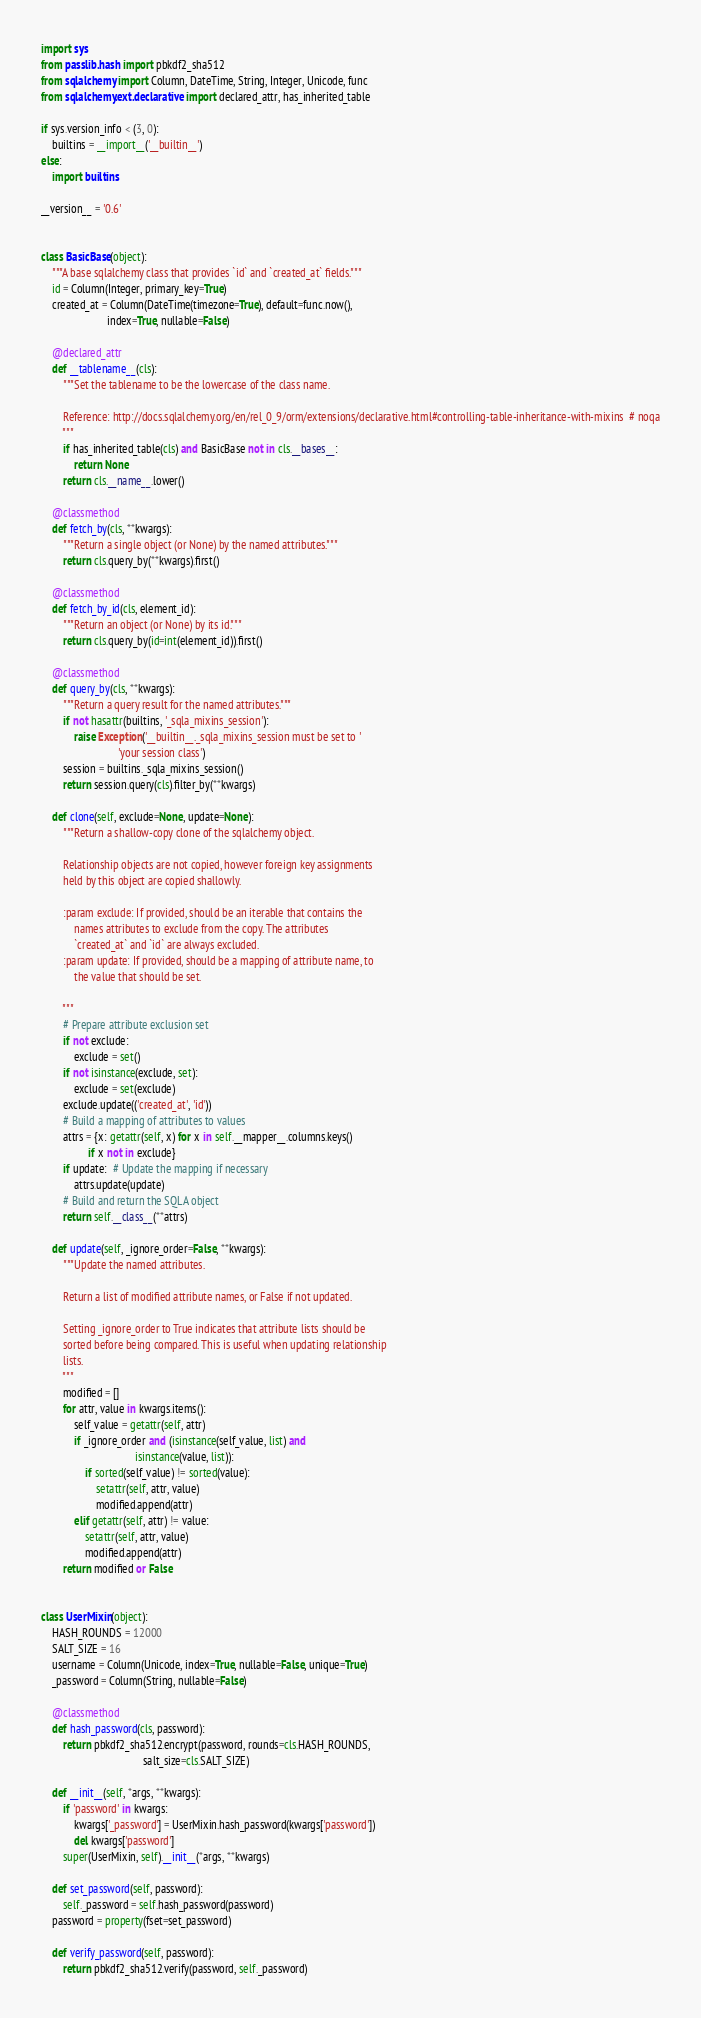Convert code to text. <code><loc_0><loc_0><loc_500><loc_500><_Python_>import sys
from passlib.hash import pbkdf2_sha512
from sqlalchemy import Column, DateTime, String, Integer, Unicode, func
from sqlalchemy.ext.declarative import declared_attr, has_inherited_table

if sys.version_info < (3, 0):
    builtins = __import__('__builtin__')
else:
    import builtins

__version__ = '0.6'


class BasicBase(object):
    """A base sqlalchemy class that provides `id` and `created_at` fields."""
    id = Column(Integer, primary_key=True)
    created_at = Column(DateTime(timezone=True), default=func.now(),
                        index=True, nullable=False)

    @declared_attr
    def __tablename__(cls):
        """Set the tablename to be the lowercase of the class name.

        Reference: http://docs.sqlalchemy.org/en/rel_0_9/orm/extensions/declarative.html#controlling-table-inheritance-with-mixins  # noqa
        """
        if has_inherited_table(cls) and BasicBase not in cls.__bases__:
            return None
        return cls.__name__.lower()

    @classmethod
    def fetch_by(cls, **kwargs):
        """Return a single object (or None) by the named attributes."""
        return cls.query_by(**kwargs).first()

    @classmethod
    def fetch_by_id(cls, element_id):
        """Return an object (or None) by its id."""
        return cls.query_by(id=int(element_id)).first()

    @classmethod
    def query_by(cls, **kwargs):
        """Return a query result for the named attributes."""
        if not hasattr(builtins, '_sqla_mixins_session'):
            raise Exception('__builtin__._sqla_mixins_session must be set to '
                            'your session class')
        session = builtins._sqla_mixins_session()
        return session.query(cls).filter_by(**kwargs)

    def clone(self, exclude=None, update=None):
        """Return a shallow-copy clone of the sqlalchemy object.

        Relationship objects are not copied, however foreign key assignments
        held by this object are copied shallowly.

        :param exclude: If provided, should be an iterable that contains the
            names attributes to exclude from the copy. The attributes
            `created_at` and `id` are always excluded.
        :param update: If provided, should be a mapping of attribute name, to
            the value that should be set.

        """
        # Prepare attribute exclusion set
        if not exclude:
            exclude = set()
        if not isinstance(exclude, set):
            exclude = set(exclude)
        exclude.update(('created_at', 'id'))
        # Build a mapping of attributes to values
        attrs = {x: getattr(self, x) for x in self.__mapper__.columns.keys()
                 if x not in exclude}
        if update:  # Update the mapping if necessary
            attrs.update(update)
        # Build and return the SQLA object
        return self.__class__(**attrs)

    def update(self, _ignore_order=False, **kwargs):
        """Update the named attributes.

        Return a list of modified attribute names, or False if not updated.

        Setting _ignore_order to True indicates that attribute lists should be
        sorted before being compared. This is useful when updating relationship
        lists.
        """
        modified = []
        for attr, value in kwargs.items():
            self_value = getattr(self, attr)
            if _ignore_order and (isinstance(self_value, list) and
                                  isinstance(value, list)):
                if sorted(self_value) != sorted(value):
                    setattr(self, attr, value)
                    modified.append(attr)
            elif getattr(self, attr) != value:
                setattr(self, attr, value)
                modified.append(attr)
        return modified or False


class UserMixin(object):
    HASH_ROUNDS = 12000
    SALT_SIZE = 16
    username = Column(Unicode, index=True, nullable=False, unique=True)
    _password = Column(String, nullable=False)

    @classmethod
    def hash_password(cls, password):
        return pbkdf2_sha512.encrypt(password, rounds=cls.HASH_ROUNDS,
                                     salt_size=cls.SALT_SIZE)

    def __init__(self, *args, **kwargs):
        if 'password' in kwargs:
            kwargs['_password'] = UserMixin.hash_password(kwargs['password'])
            del kwargs['password']
        super(UserMixin, self).__init__(*args, **kwargs)

    def set_password(self, password):
        self._password = self.hash_password(password)
    password = property(fset=set_password)

    def verify_password(self, password):
        return pbkdf2_sha512.verify(password, self._password)
</code> 